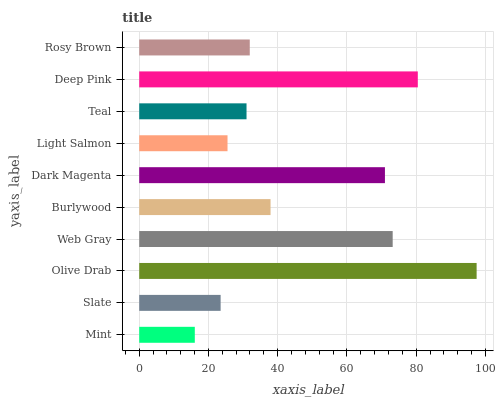Is Mint the minimum?
Answer yes or no. Yes. Is Olive Drab the maximum?
Answer yes or no. Yes. Is Slate the minimum?
Answer yes or no. No. Is Slate the maximum?
Answer yes or no. No. Is Slate greater than Mint?
Answer yes or no. Yes. Is Mint less than Slate?
Answer yes or no. Yes. Is Mint greater than Slate?
Answer yes or no. No. Is Slate less than Mint?
Answer yes or no. No. Is Burlywood the high median?
Answer yes or no. Yes. Is Rosy Brown the low median?
Answer yes or no. Yes. Is Olive Drab the high median?
Answer yes or no. No. Is Mint the low median?
Answer yes or no. No. 